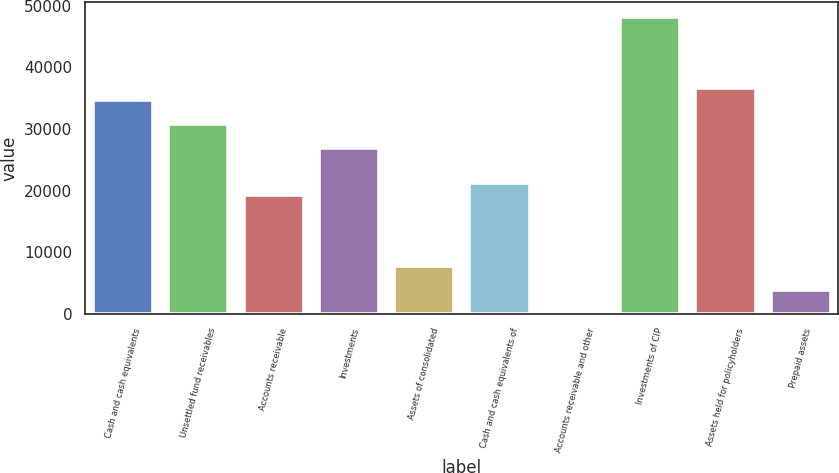Convert chart. <chart><loc_0><loc_0><loc_500><loc_500><bar_chart><fcel>Cash and cash equivalents<fcel>Unsettled fund receivables<fcel>Accounts receivable<fcel>Investments<fcel>Assets of consolidated<fcel>Cash and cash equivalents of<fcel>Accounts receivable and other<fcel>Investments of CIP<fcel>Assets held for policyholders<fcel>Prepaid assets<nl><fcel>34640.3<fcel>30797.8<fcel>19270.5<fcel>26955.4<fcel>7743.18<fcel>21191.7<fcel>58.3<fcel>48088.8<fcel>36561.5<fcel>3900.74<nl></chart> 